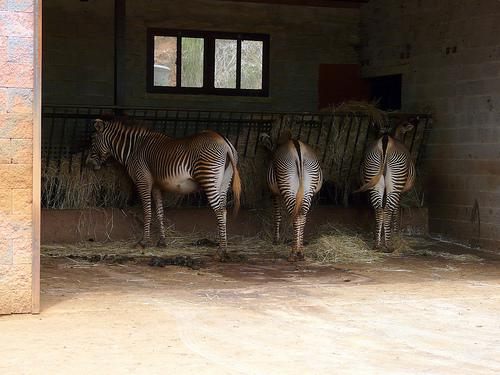Question: what are they doing?
Choices:
A. Sleeping.
B. Eating.
C. Drinking.
D. Playing.
Answer with the letter. Answer: B Question: what are they eating?
Choices:
A. Hay.
B. Grass.
C. Kibble.
D. Flowers.
Answer with the letter. Answer: A Question: how many zebras are there?
Choices:
A. More than 10.
B. One.
C. 3.
D. Five.
Answer with the letter. Answer: C 